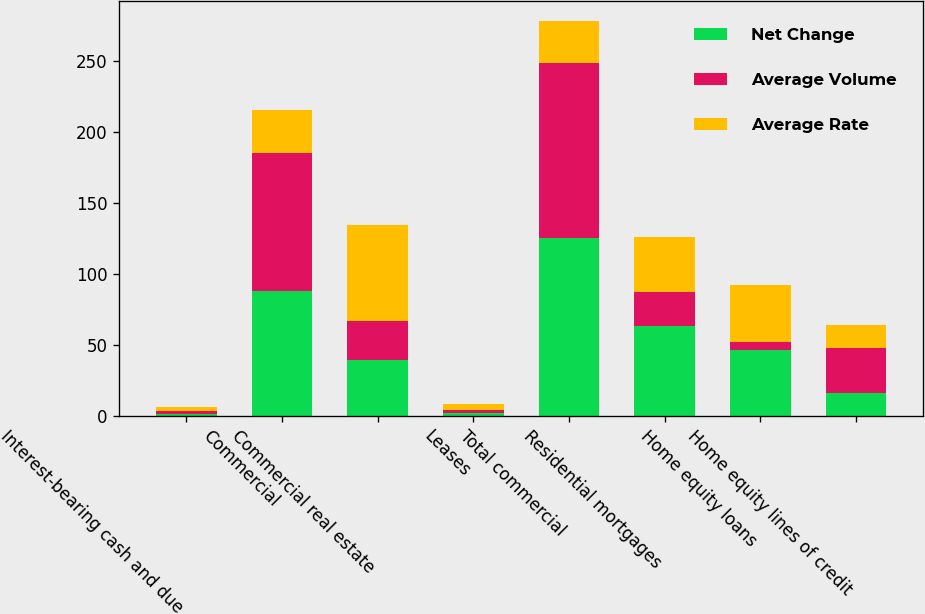Convert chart to OTSL. <chart><loc_0><loc_0><loc_500><loc_500><stacked_bar_chart><ecel><fcel>Interest-bearing cash and due<fcel>Commercial<fcel>Commercial real estate<fcel>Leases<fcel>Total commercial<fcel>Residential mortgages<fcel>Home equity loans<fcel>Home equity lines of credit<nl><fcel>Net Change<fcel>1<fcel>88<fcel>39<fcel>2<fcel>125<fcel>63<fcel>46<fcel>16<nl><fcel>Average Volume<fcel>2<fcel>97<fcel>28<fcel>2<fcel>123<fcel>24<fcel>6<fcel>32<nl><fcel>Average Rate<fcel>3<fcel>30<fcel>67<fcel>4<fcel>30<fcel>39<fcel>40<fcel>16<nl></chart> 